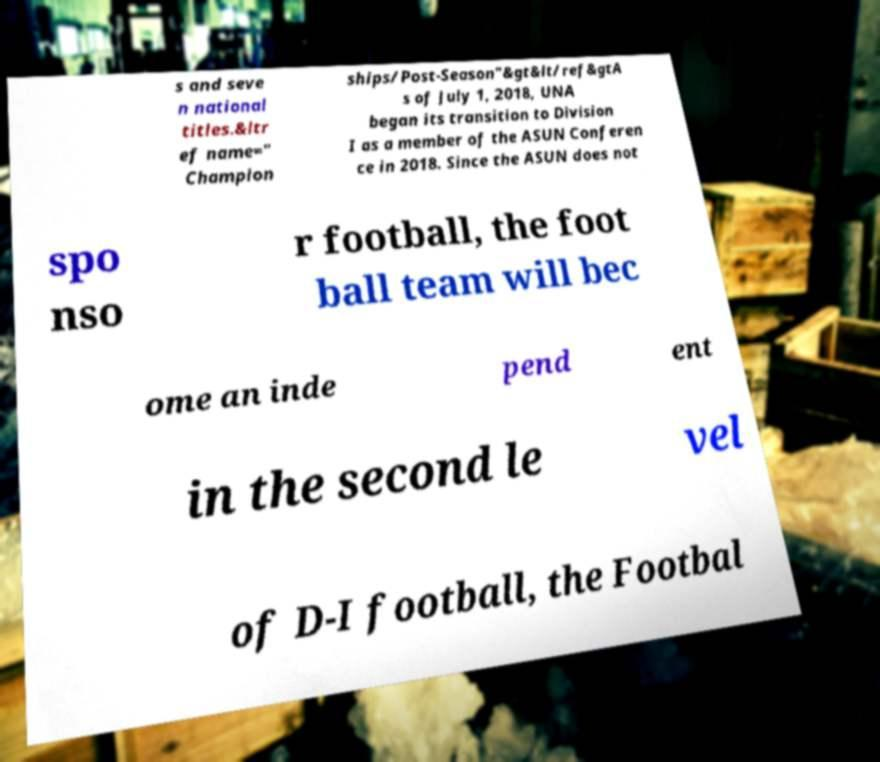Please read and relay the text visible in this image. What does it say? s and seve n national titles.&ltr ef name=" Champion ships/Post-Season"&gt&lt/ref&gtA s of July 1, 2018, UNA began its transition to Division I as a member of the ASUN Conferen ce in 2018. Since the ASUN does not spo nso r football, the foot ball team will bec ome an inde pend ent in the second le vel of D-I football, the Footbal 